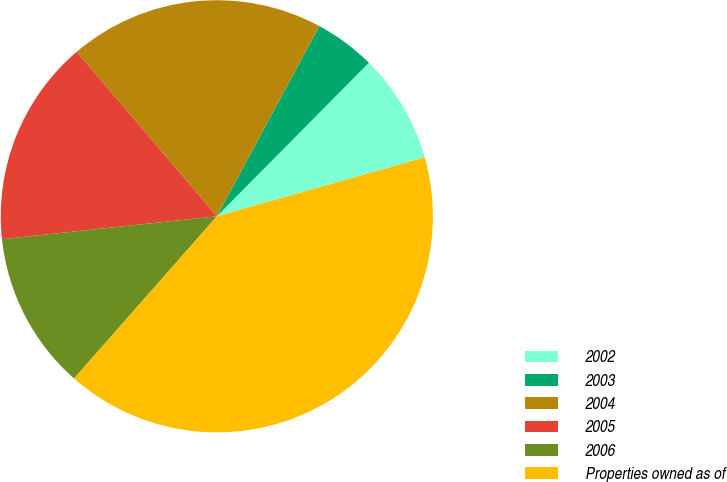Convert chart to OTSL. <chart><loc_0><loc_0><loc_500><loc_500><pie_chart><fcel>2002<fcel>2003<fcel>2004<fcel>2005<fcel>2006<fcel>Properties owned as of<nl><fcel>8.19%<fcel>4.56%<fcel>19.09%<fcel>15.46%<fcel>11.82%<fcel>40.88%<nl></chart> 